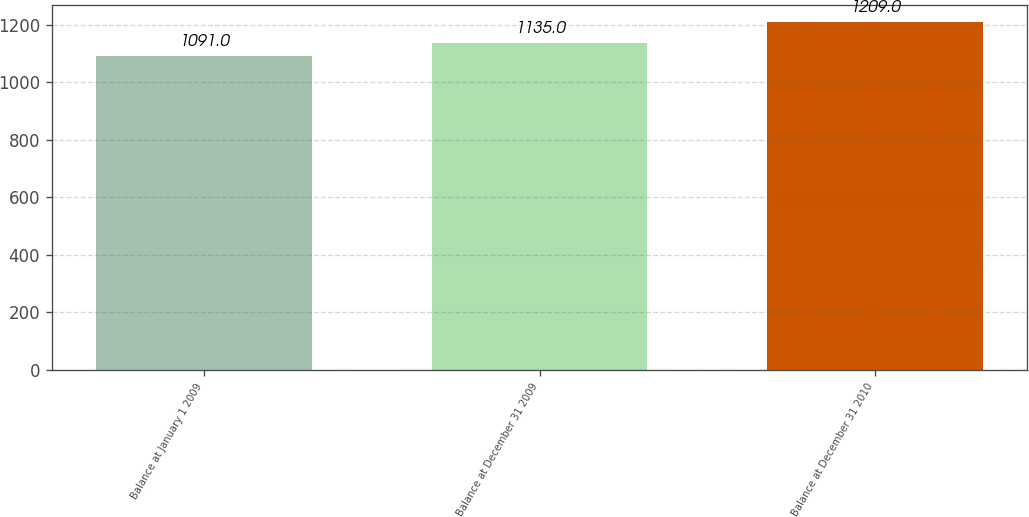Convert chart. <chart><loc_0><loc_0><loc_500><loc_500><bar_chart><fcel>Balance at January 1 2009<fcel>Balance at December 31 2009<fcel>Balance at December 31 2010<nl><fcel>1091<fcel>1135<fcel>1209<nl></chart> 